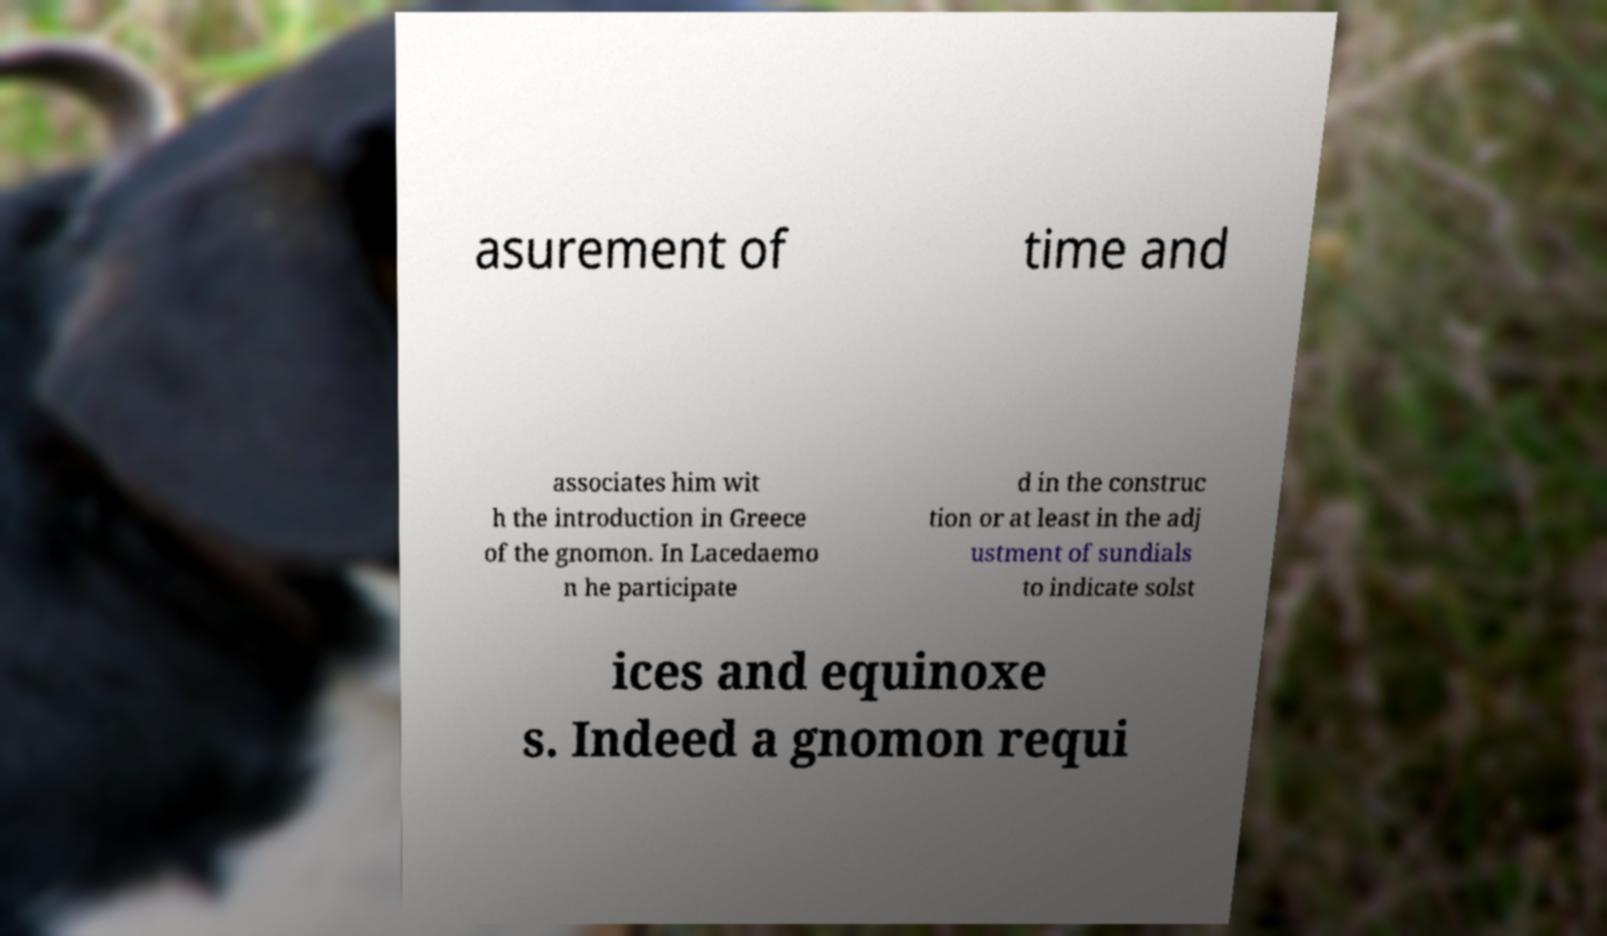I need the written content from this picture converted into text. Can you do that? asurement of time and associates him wit h the introduction in Greece of the gnomon. In Lacedaemo n he participate d in the construc tion or at least in the adj ustment of sundials to indicate solst ices and equinoxe s. Indeed a gnomon requi 